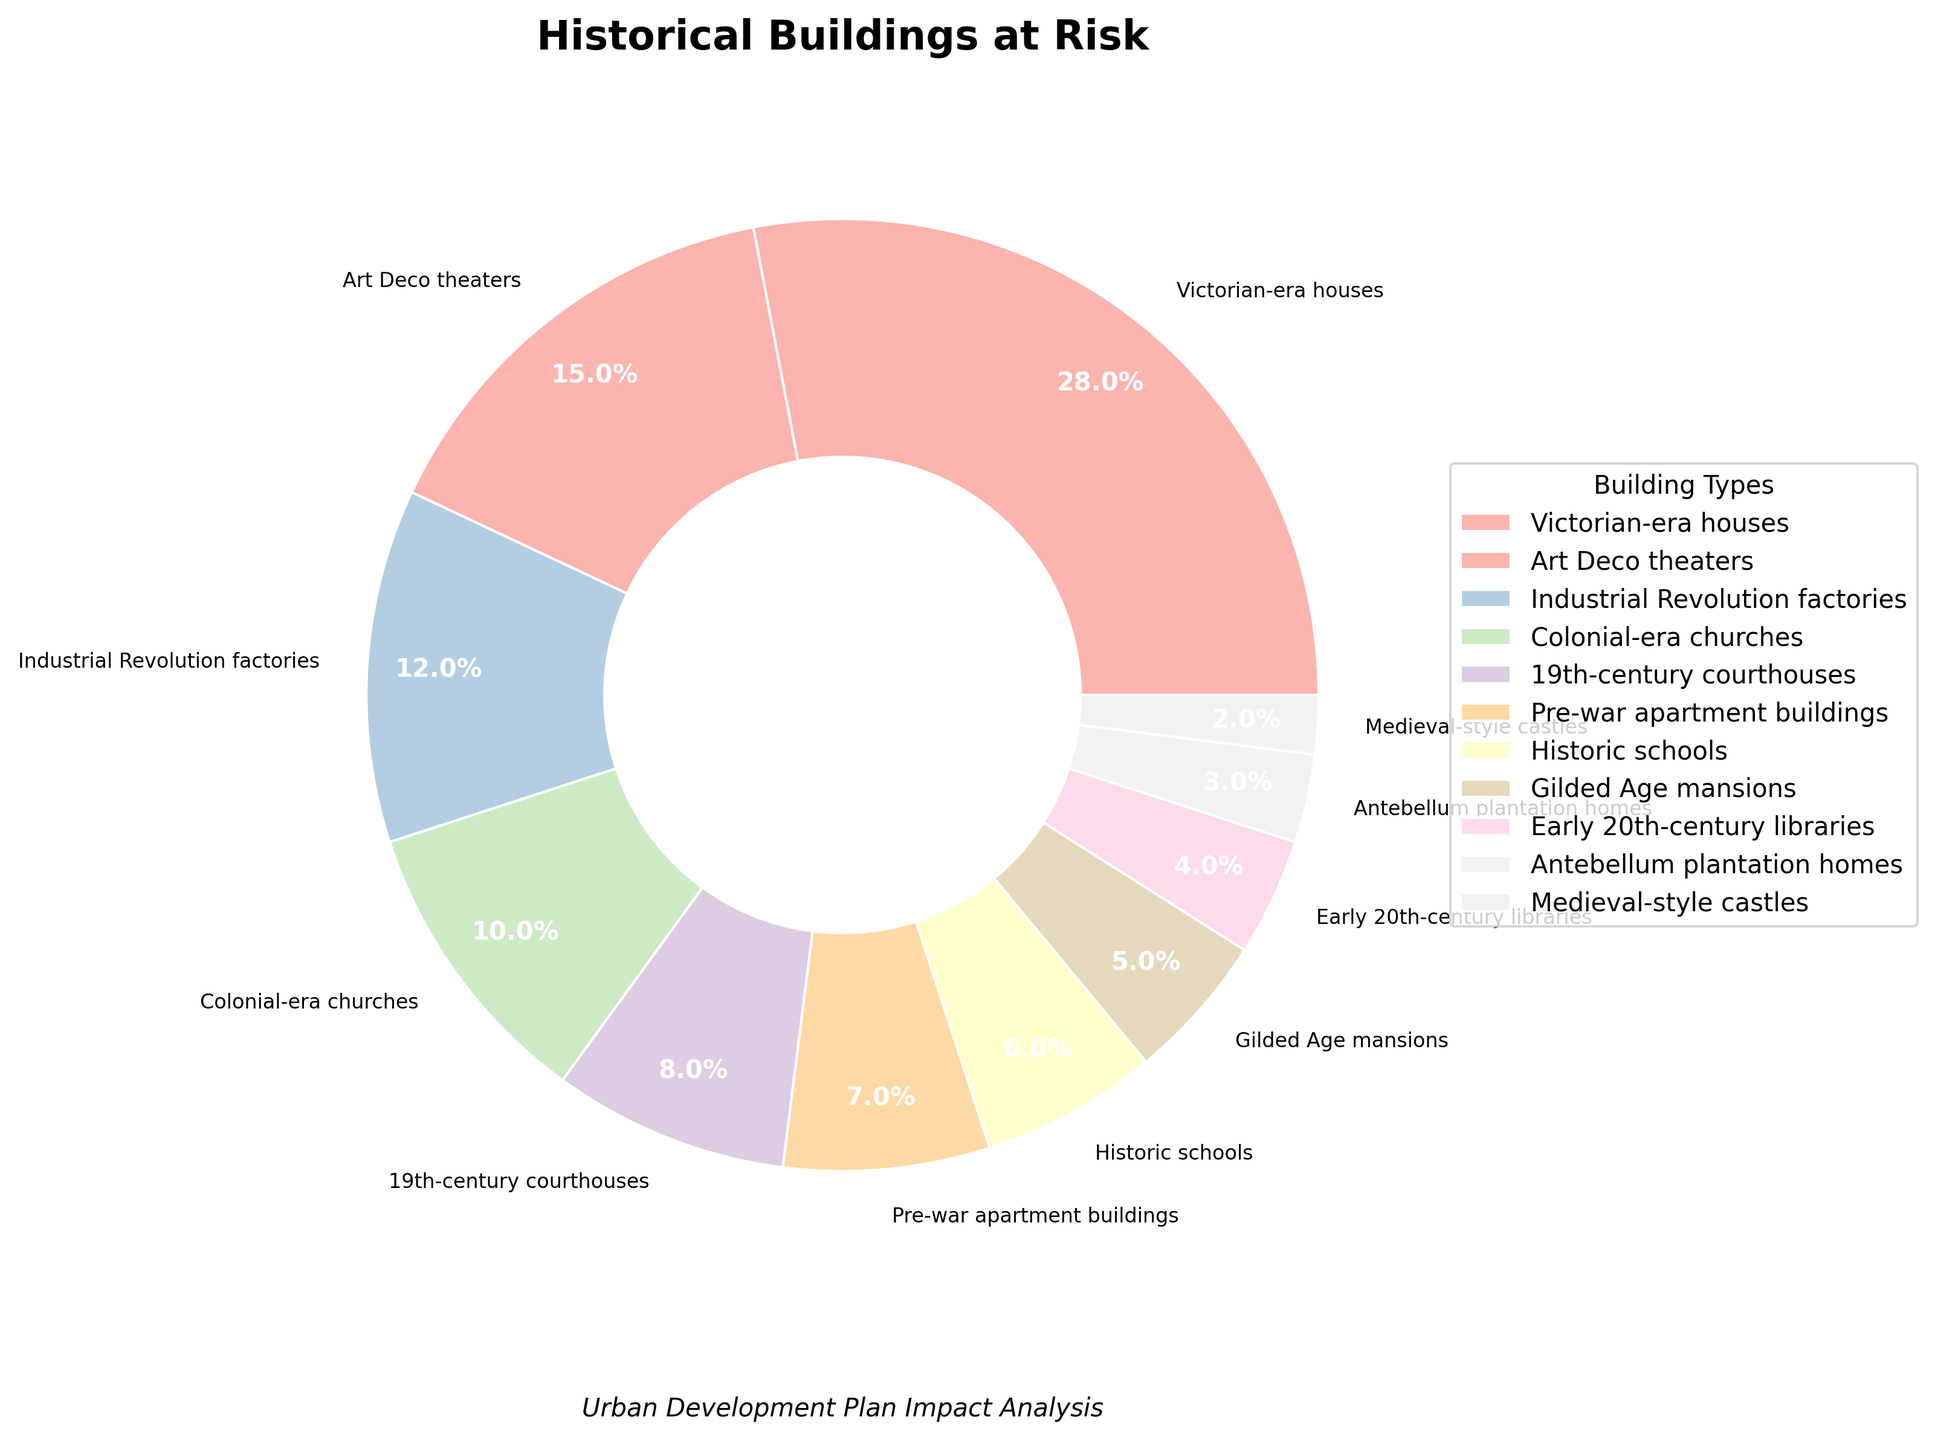What percentage of the buildings at risk are from the Victorian era? The pie chart shows the percentages of different types of historical buildings at risk. By referring to the slice labeled "Victorian-era houses," we can see its corresponding percentage.
Answer: 28% Which type of historical building at risk has the smallest share compared to others? The pie chart segments vary in size, and the smallest wedge represents the type of building with the smallest percentage. The "Medieval-style castles" segment is the smallest.
Answer: Medieval-style castles What is the combined percentage of buildings at risk from the Industrial Revolution factories and Colonial-era churches? Adding the percentages of Industrial Revolution factories (12%) and Colonial-era churches (10%) gives: 12% + 10% = 22%.
Answer: 22% Which category of historical buildings has a higher percentage at risk: Art Deco theaters or 19th-century courthouses? By comparing the wedge sizes in the pie chart, we observe that Art Deco theaters have a larger segment than 19th-century courthouses. Art Deco theaters are at 15% while 19th-century courthouses are at 8%.
Answer: Art Deco theaters How much more percentage of buildings at risk are Victorian-era houses compared to Gilded Age mansions? Subtract the percentage of Gilded Age mansions (5%) from that of Victorian-era houses (28%) to get: 28% - 5% = 23%.
Answer: 23% What percentage of the buildings at risk are from buildings older than the 19th century (Antebellum plantation homes and Medieval-style castles)? Adding the percentages of Antebellum plantation homes (3%) and Medieval-style castles (2%) gives: 3% + 2% = 5%.
Answer: 5% How does the percentage of pre-war apartment buildings compare to that of historic schools? The pie chart shows the percentage slices, noting that pre-war apartment buildings have 7% and historic schools have 6%. Comparing these shows that pre-war apartment buildings have a slightly higher percentage.
Answer: Pre-war apartment buildings have a higher percentage What is the total percentage of buildings from the 19th century at risk (Victorian-era houses, 19th-century courthouses, and Industrial Revolution factories)? Adding the percentages: Victorian-era houses (28%) + 19th-century courthouses (8%) + Industrial Revolution factories (12%) gives: 28% + 8% + 12% = 48%.
Answer: 48% What percentage of the buildings at risk are Library buildings? Referencing the pie chart label for library buildings shows that Early 20th-century libraries are at 4%.
Answer: 4% 